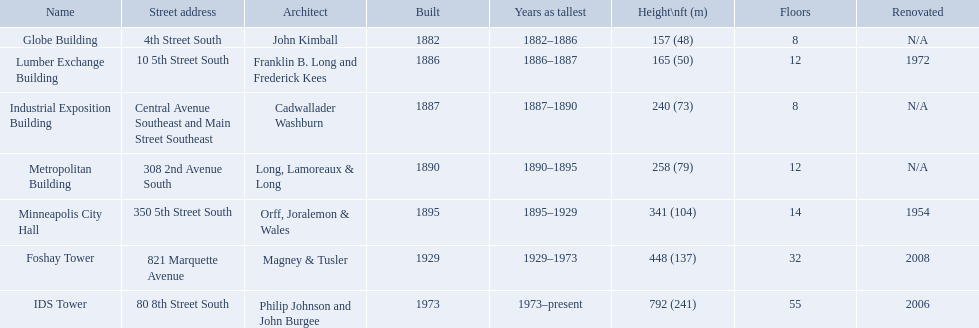What years was 240 ft considered tall? 1887–1890. What building held this record? Industrial Exposition Building. What are the tallest buildings in minneapolis? Globe Building, Lumber Exchange Building, Industrial Exposition Building, Metropolitan Building, Minneapolis City Hall, Foshay Tower, IDS Tower. What is the height of the metropolitan building? 258 (79). What is the height of the lumber exchange building? 165 (50). Write the full table. {'header': ['Name', 'Street address', 'Architect', 'Built', 'Years as tallest', 'Height\\nft (m)', 'Floors', 'Renovated'], 'rows': [['Globe Building', '4th Street South', 'John Kimball', '1882', '1882–1886', '157 (48)', '8', 'N/A'], ['Lumber Exchange Building', '10 5th Street South', 'Franklin B. Long and Frederick Kees', '1886', '1886–1887', '165 (50)', '12', '1972'], ['Industrial Exposition Building', 'Central Avenue Southeast and Main Street Southeast', 'Cadwallader Washburn', '1887', '1887–1890', '240 (73)', '8', 'N/A'], ['Metropolitan Building', '308 2nd Avenue South', 'Long, Lamoreaux & Long', '1890', '1890–1895', '258 (79)', '12', 'N/A'], ['Minneapolis City Hall', '350 5th Street South', 'Orff, Joralemon & Wales', '1895', '1895–1929', '341 (104)', '14', '1954'], ['Foshay Tower', '821 Marquette Avenue', 'Magney & Tusler', '1929', '1929–1973', '448 (137)', '32', '2008'], ['IDS Tower', '80 8th Street South', 'Philip Johnson and John Burgee', '1973', '1973–present', '792 (241)', '55', '2006']]} Of those two which is taller? Metropolitan Building. What are all the building names? Globe Building, Lumber Exchange Building, Industrial Exposition Building, Metropolitan Building, Minneapolis City Hall, Foshay Tower, IDS Tower. And their heights? 157 (48), 165 (50), 240 (73), 258 (79), 341 (104), 448 (137), 792 (241). Between metropolitan building and lumber exchange building, which is taller? Metropolitan Building. How many floors does the globe building have? 8. Which building has 14 floors? Minneapolis City Hall. The lumber exchange building has the same number of floors as which building? Metropolitan Building. How many floors does the lumber exchange building have? 12. What other building has 12 floors? Metropolitan Building. 